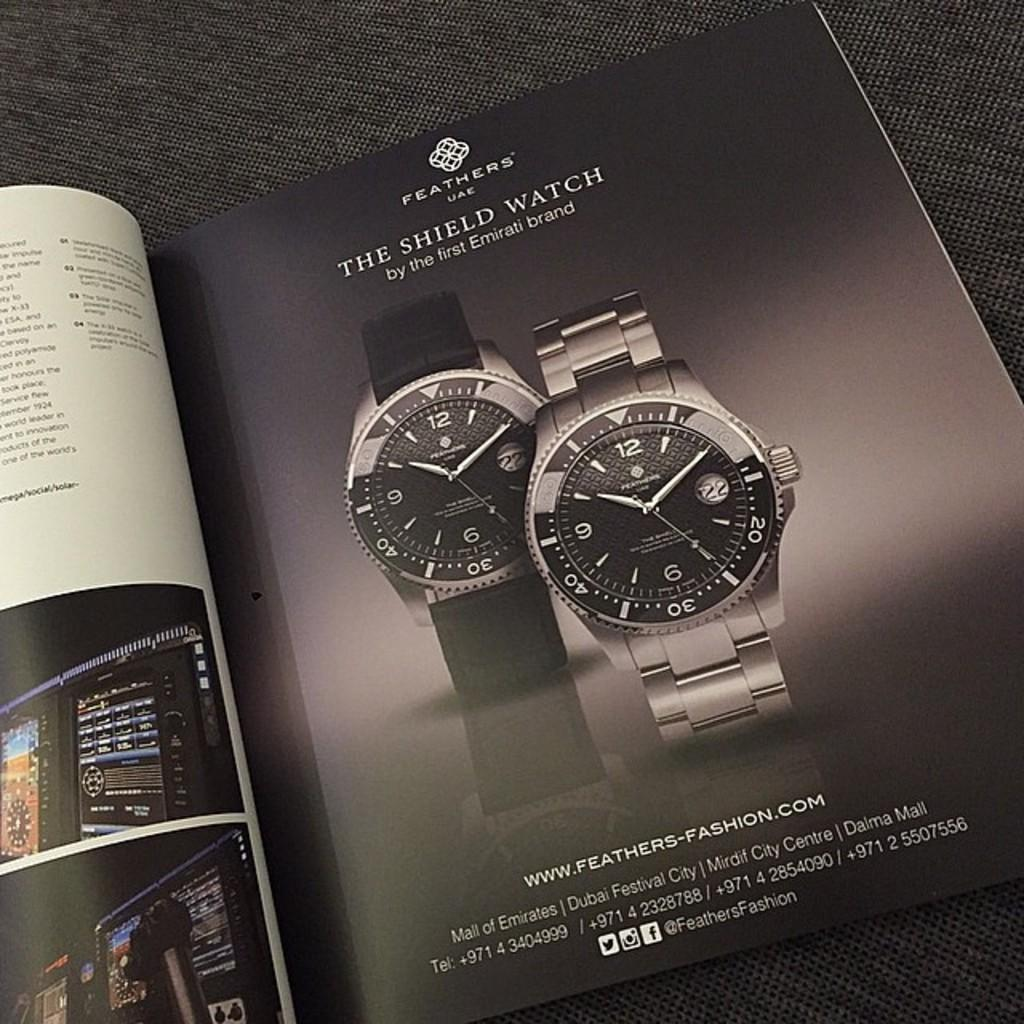<image>
Give a short and clear explanation of the subsequent image. A magazine ad for The Shield Watch shows two watches on a black background. 